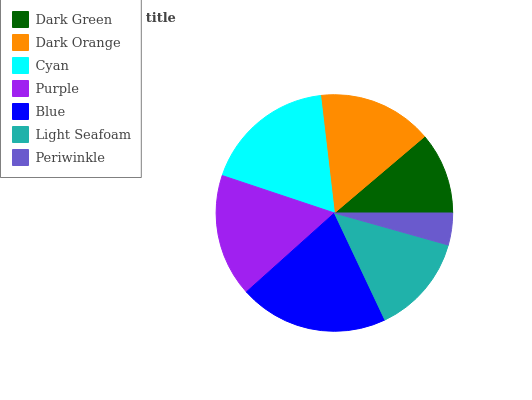Is Periwinkle the minimum?
Answer yes or no. Yes. Is Blue the maximum?
Answer yes or no. Yes. Is Dark Orange the minimum?
Answer yes or no. No. Is Dark Orange the maximum?
Answer yes or no. No. Is Dark Orange greater than Dark Green?
Answer yes or no. Yes. Is Dark Green less than Dark Orange?
Answer yes or no. Yes. Is Dark Green greater than Dark Orange?
Answer yes or no. No. Is Dark Orange less than Dark Green?
Answer yes or no. No. Is Dark Orange the high median?
Answer yes or no. Yes. Is Dark Orange the low median?
Answer yes or no. Yes. Is Blue the high median?
Answer yes or no. No. Is Dark Green the low median?
Answer yes or no. No. 